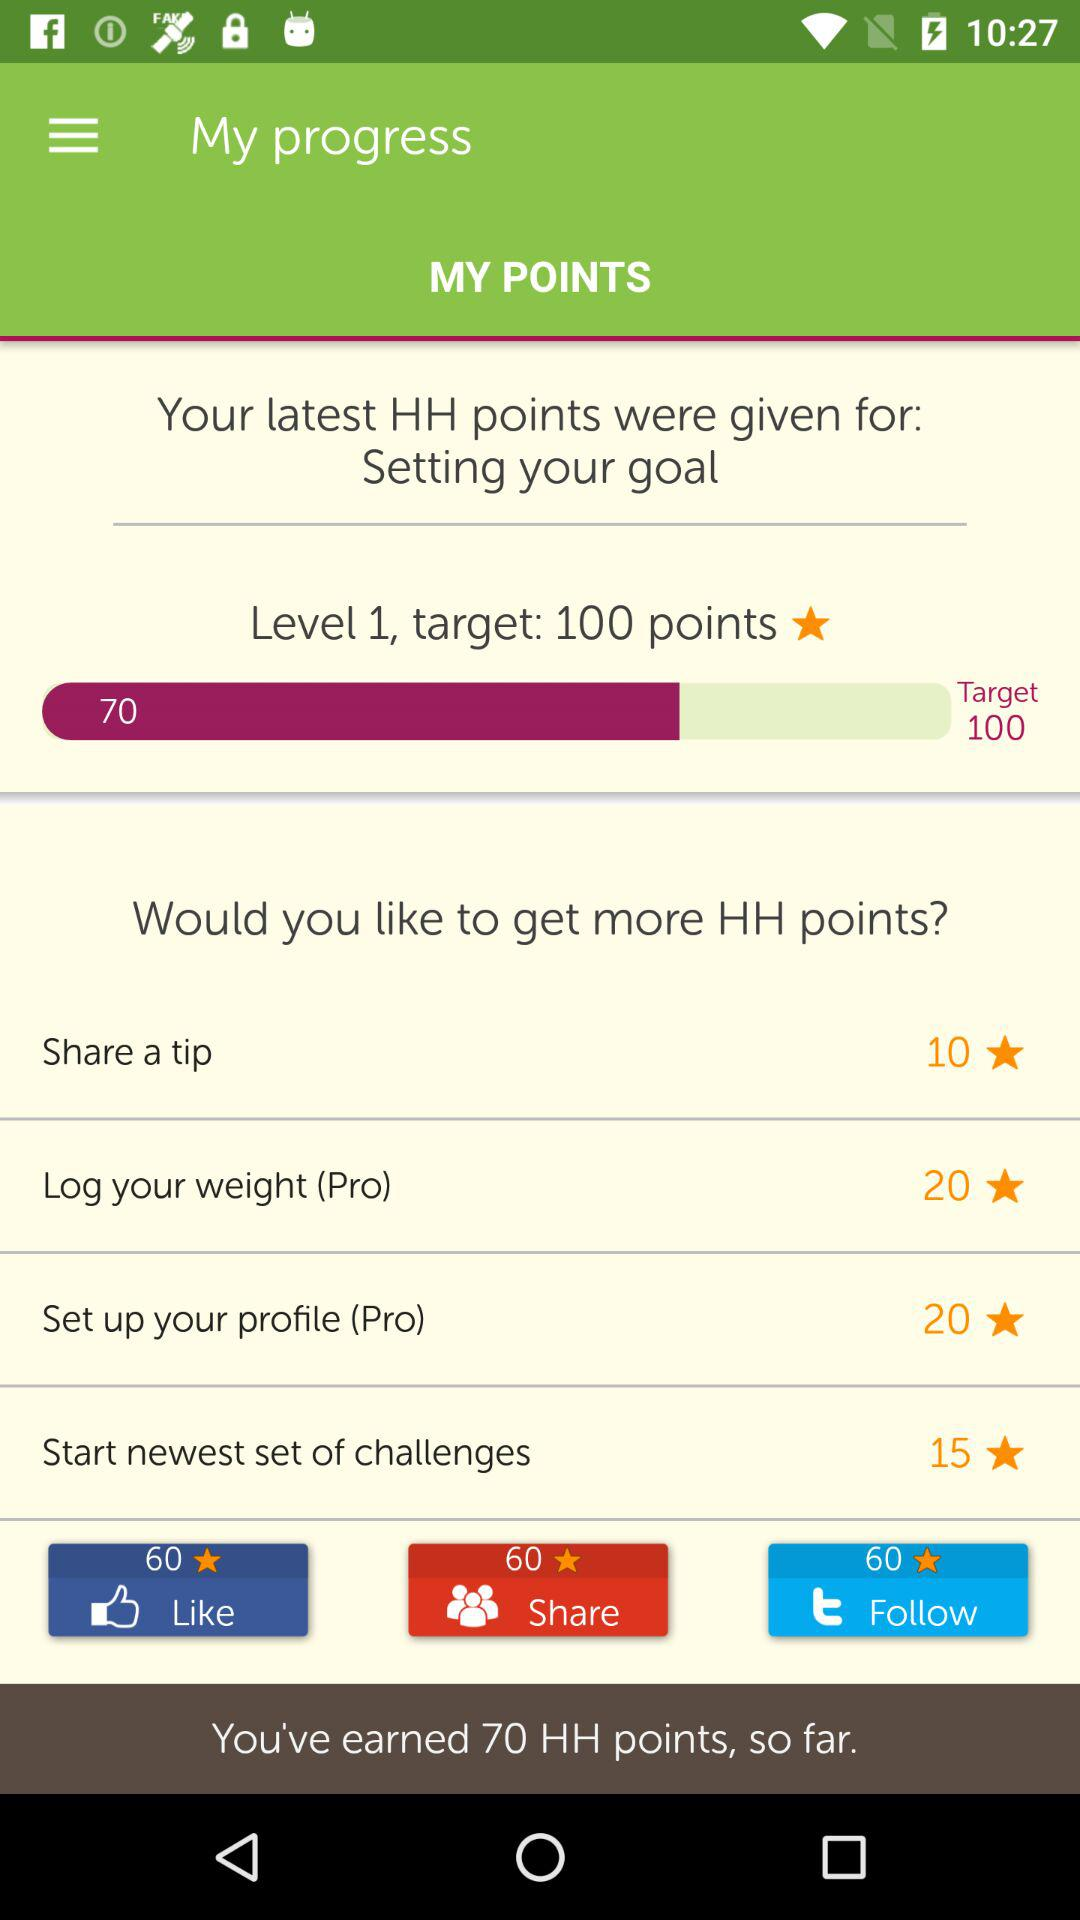How many points do I need to reach my goal?
Answer the question using a single word or phrase. 100 